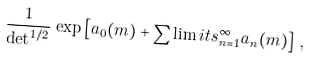<formula> <loc_0><loc_0><loc_500><loc_500>\frac { 1 } { \det ^ { 1 / 2 } } \, \exp \left [ a _ { 0 } ( m ) + \sum \lim i t s _ { n = 1 } ^ { \infty } a _ { n } ( m ) \right ] \, ,</formula> 